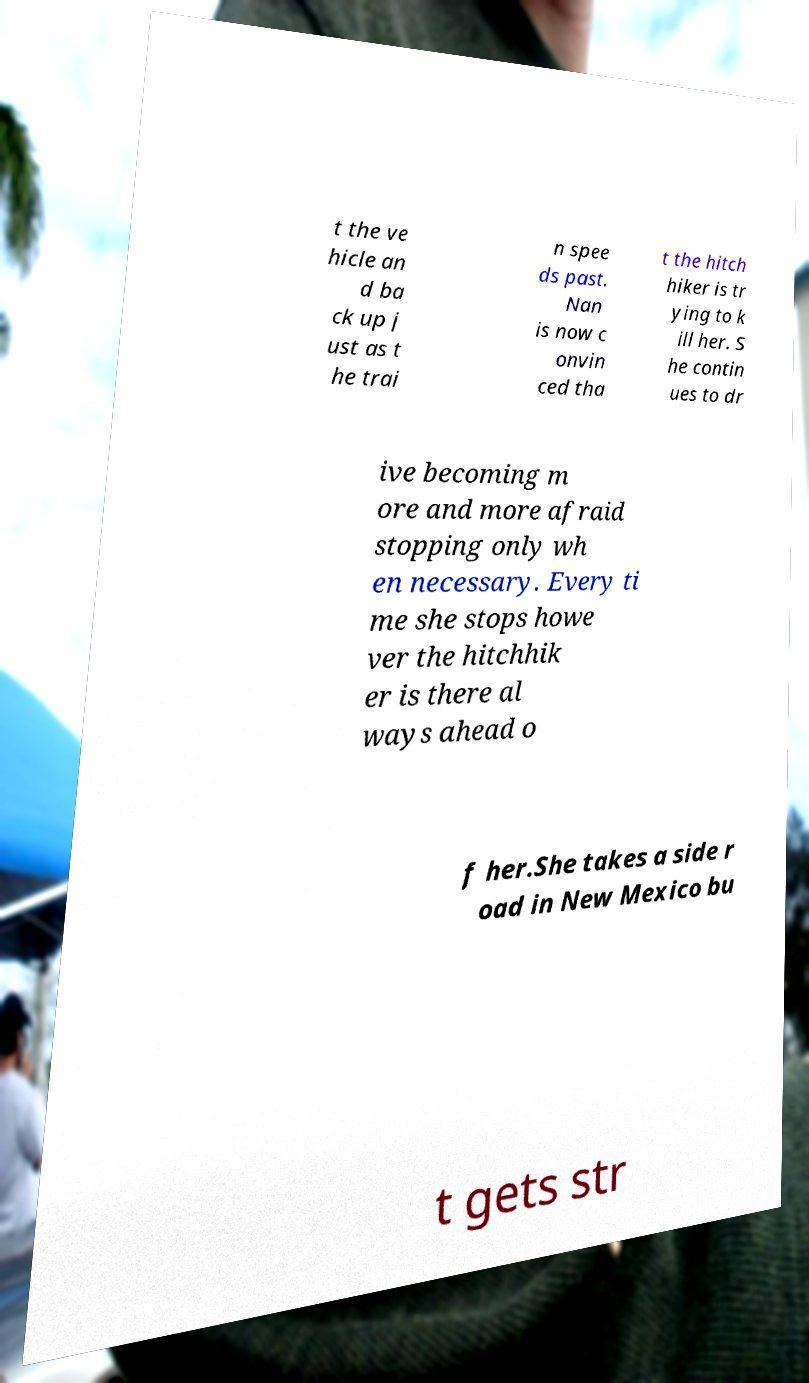Could you assist in decoding the text presented in this image and type it out clearly? t the ve hicle an d ba ck up j ust as t he trai n spee ds past. Nan is now c onvin ced tha t the hitch hiker is tr ying to k ill her. S he contin ues to dr ive becoming m ore and more afraid stopping only wh en necessary. Every ti me she stops howe ver the hitchhik er is there al ways ahead o f her.She takes a side r oad in New Mexico bu t gets str 